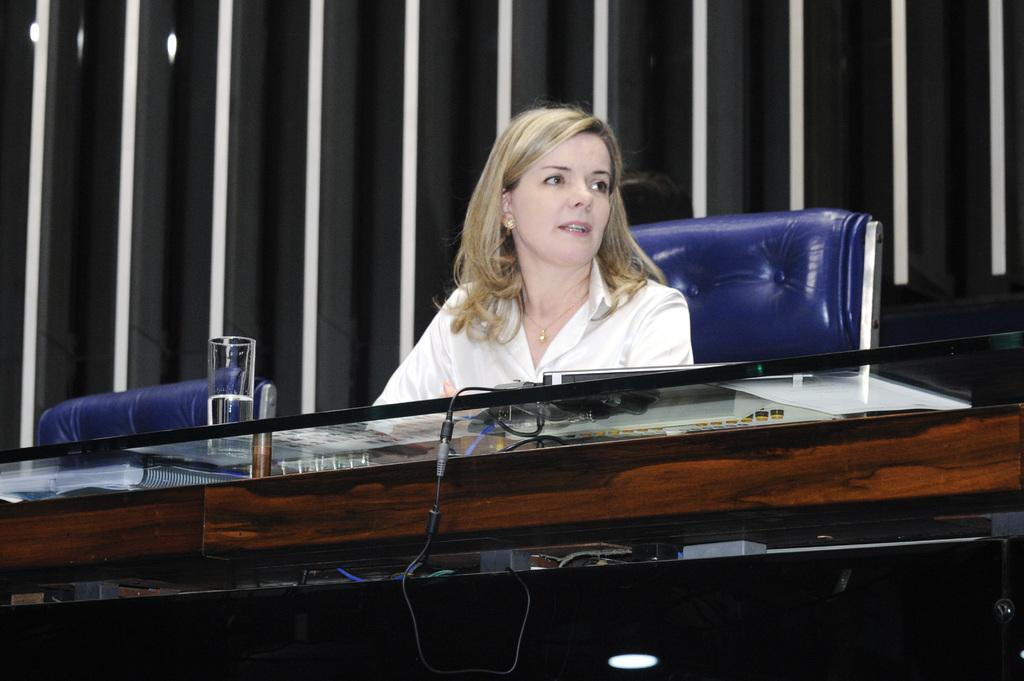What is the woman in the image doing? The woman is sitting in the chair. What is in front of the woman? There is a glass table in front of the woman. What objects are on the table? There is a glass object and a laptop on the table. What can be seen in the background of the image? There is a wall in the background. What type of pet is sitting next to the woman in the image? There is no pet present in the image. What journey is the woman planning to take, as indicated by the objects on the table? There is no indication of a journey in the image; the objects on the table are a glass object and a laptop. 